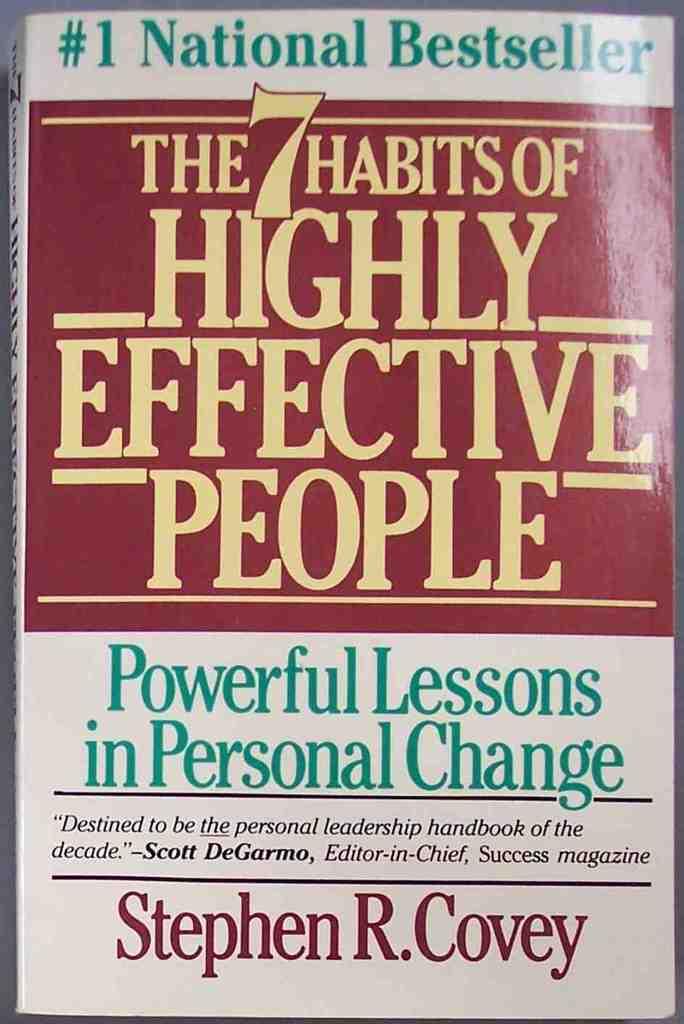Who is the author of this book?
Provide a short and direct response. Stephen r covey. How many habits is this book about?
Ensure brevity in your answer.  7. 